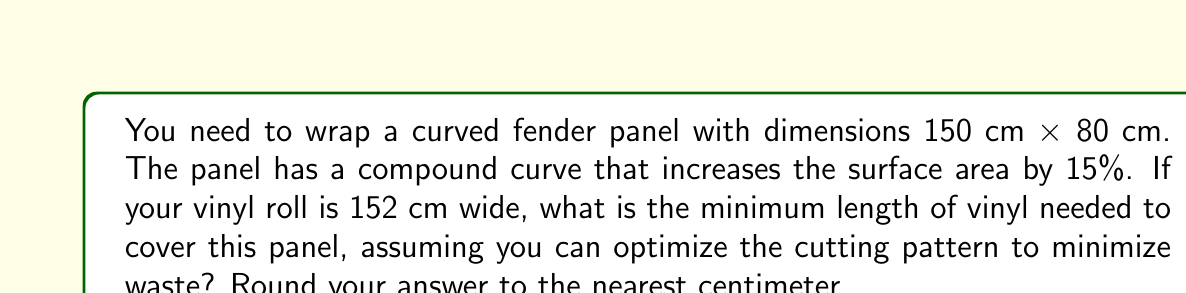Teach me how to tackle this problem. To solve this problem, we need to follow these steps:

1. Calculate the flat surface area of the panel:
   $A_{flat} = 150 \text{ cm} \times 80 \text{ cm} = 12,000 \text{ cm}^2$

2. Account for the compound curve by increasing the surface area by 15%:
   $A_{curved} = A_{flat} \times 1.15 = 12,000 \text{ cm}^2 \times 1.15 = 13,800 \text{ cm}^2$

3. Determine the width of vinyl we can use:
   The vinyl roll is 152 cm wide, which is wider than the panel. We can use the full 80 cm width of the panel.

4. Calculate the length of vinyl needed:
   $$L = \frac{A_{curved}}{W} = \frac{13,800 \text{ cm}^2}{80 \text{ cm}} = 172.5 \text{ cm}$$

5. Round to the nearest centimeter:
   172.5 cm rounds to 173 cm

This calculation assumes that we can optimize the cutting pattern to use the full width of the panel, minimizing waste. In practice, you might need to add a small allowance for trimming and wrapping around edges, but this represents the theoretical minimum based on the surface area.
Answer: 173 cm 